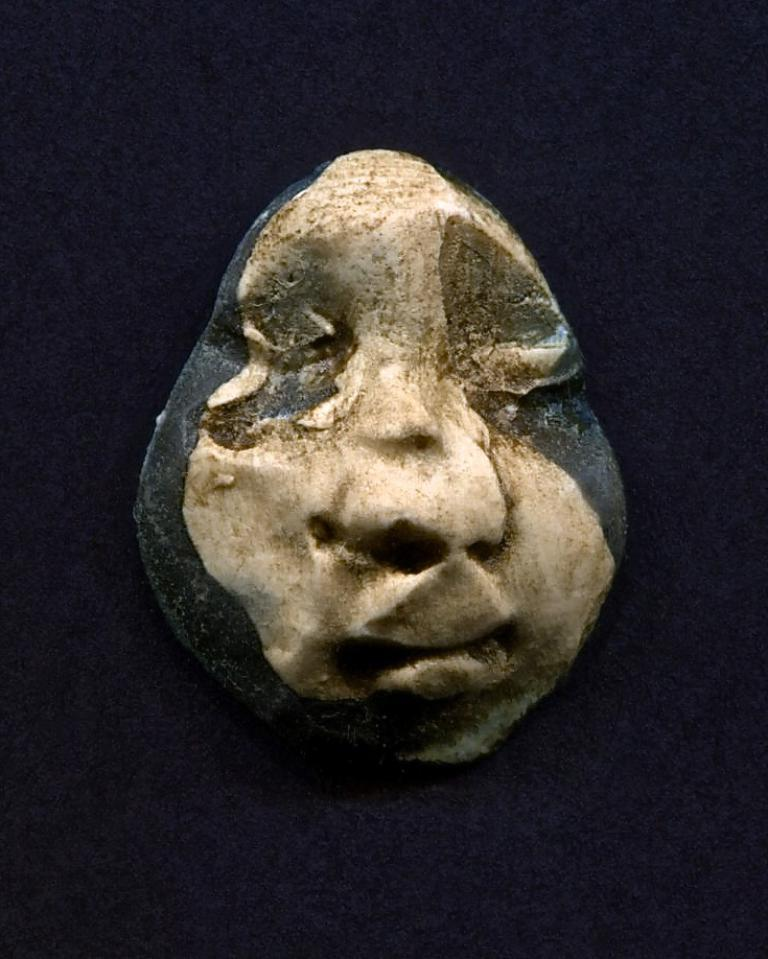What is the main subject of the image? There is a sculpture in the middle of the image. What can be observed about the background of the image? The background of the image is dark. What type of shoes is the sculpture wearing in the image? The sculpture is not wearing any shoes, as it is an inanimate object and not a person. 